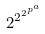<formula> <loc_0><loc_0><loc_500><loc_500>2 ^ { 2 ^ { 2 ^ { p ^ { a } } } }</formula> 